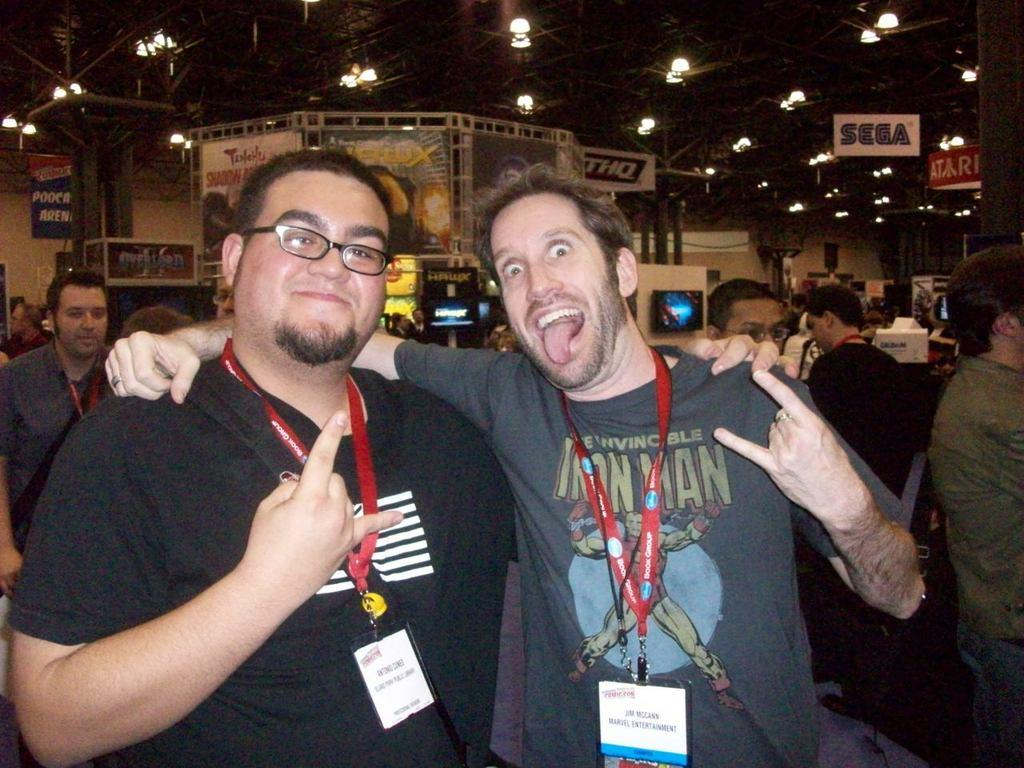How many people are present in the image? There are people in the image, but the exact number is not specified. What are some accessories that people are wearing in the image? Some people are wearing ID cards and glasses in the image. What can be seen in the background of the image? In the background of the image, there are lights, boards, and screens. What is visible at the top of the image? There is a roof visible at the top of the image. What type of salt is being used to season the food in the image? There is no food or salt present in the image; it features people with ID cards and glasses, as well as background elements like lights, boards, and screens. 